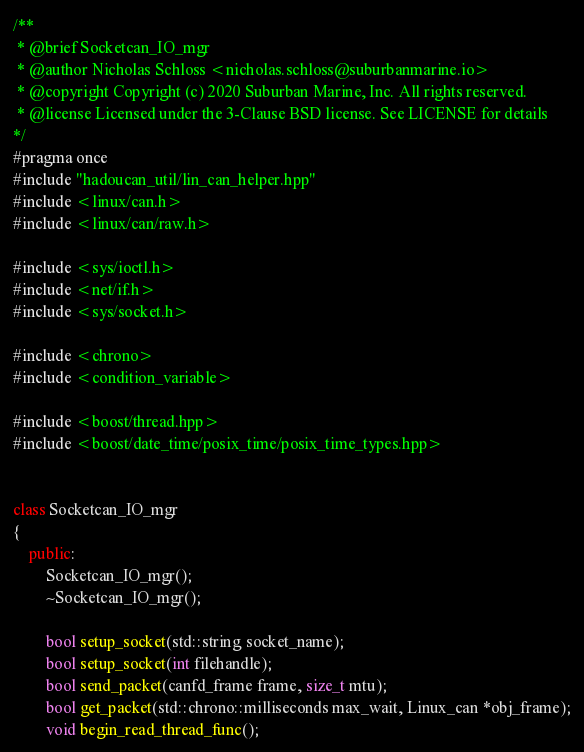Convert code to text. <code><loc_0><loc_0><loc_500><loc_500><_C++_>/**
 * @brief Socketcan_IO_mgr
 * @author Nicholas Schloss <nicholas.schloss@suburbanmarine.io>
 * @copyright Copyright (c) 2020 Suburban Marine, Inc. All rights reserved.
 * @license Licensed under the 3-Clause BSD license. See LICENSE for details
*/
#pragma once 
#include "hadoucan_util/lin_can_helper.hpp"
#include <linux/can.h>
#include <linux/can/raw.h>

#include <sys/ioctl.h>
#include <net/if.h>
#include <sys/socket.h>

#include <chrono>
#include <condition_variable>

#include <boost/thread.hpp>
#include <boost/date_time/posix_time/posix_time_types.hpp>


class Socketcan_IO_mgr
{
	public:
		Socketcan_IO_mgr();
		~Socketcan_IO_mgr();

		bool setup_socket(std::string socket_name);
		bool setup_socket(int filehandle);
		bool send_packet(canfd_frame frame, size_t mtu);
		bool get_packet(std::chrono::milliseconds max_wait, Linux_can *obj_frame);
		void begin_read_thread_func();</code> 